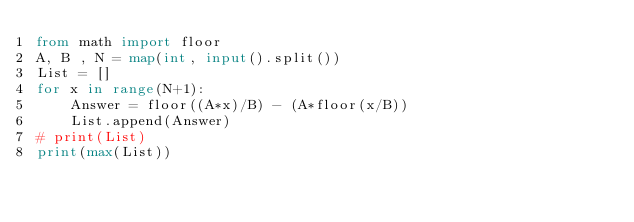<code> <loc_0><loc_0><loc_500><loc_500><_Python_>from math import floor
A, B , N = map(int, input().split())
List = []
for x in range(N+1):
    Answer = floor((A*x)/B) - (A*floor(x/B))
    List.append(Answer)
# print(List)
print(max(List))</code> 